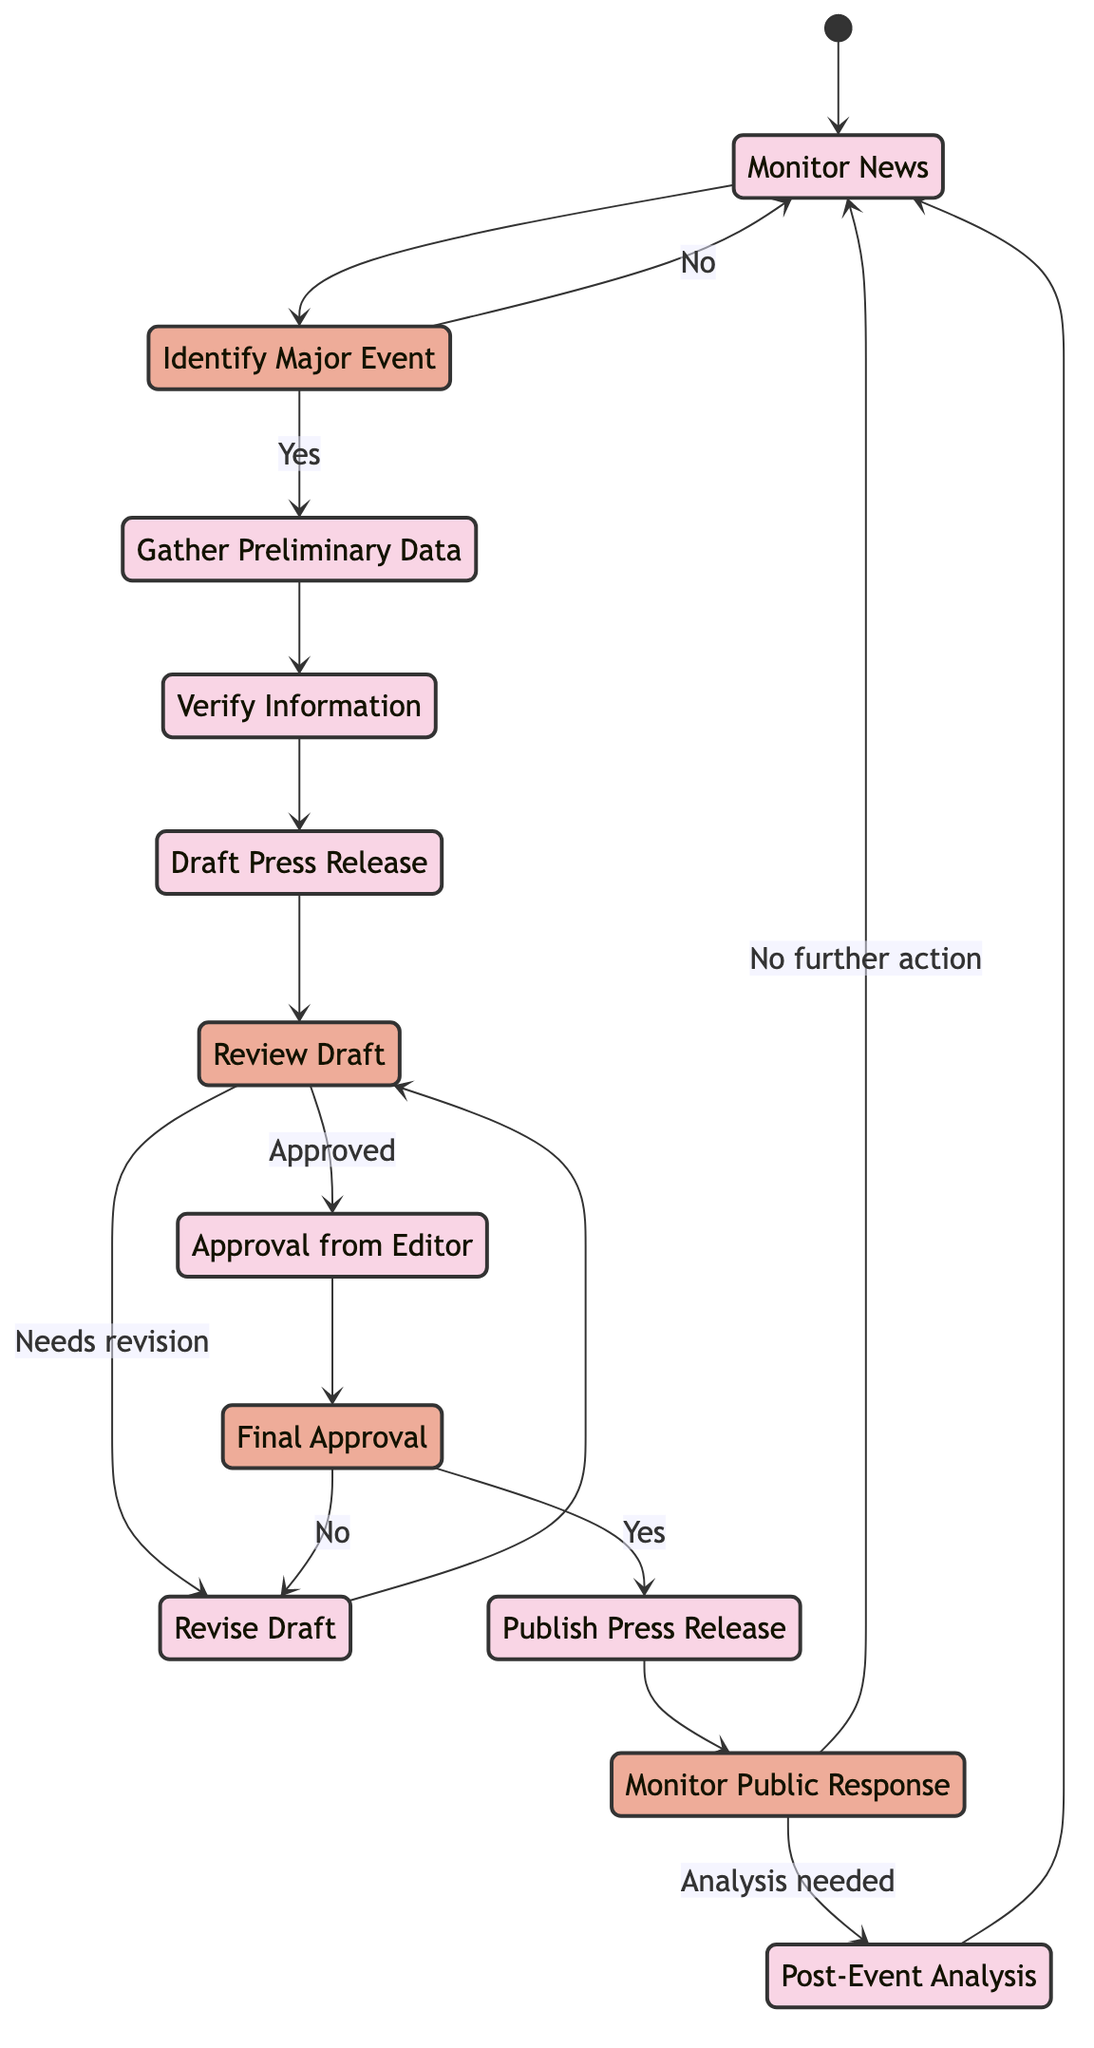What is the first activity in the workflow? The first activity in the workflow is "Monitor News". This can be seen as the starting point of the diagram, which directly leads into the next decision.
Answer: Monitor News How many decision nodes are present in the diagram? There are four decision nodes: "Identify Major Event", "Review Draft", "Final Approval", and "Monitor Public Response". Counting each of these decision points gives the total.
Answer: Four What activity follows after "Gather Preliminary Data"? Following "Gather Preliminary Data", the next activity is "Verify Information". This is indicated by the arrow connecting these two activities in the flow.
Answer: Verify Information What happens if the draft press release is approved after the review? If the draft is approved, the process moves to "Approval from Editor". This is indicated by the connection from "Review Draft" to "Approval from Editor".
Answer: Approval from Editor If the public response doesn't require further analysis, what is the next step? If no further analysis is needed, the workflow returns to "Monitor News". This is shown by the decision flow after "Monitor Public Response".
Answer: Monitor News Describe the flow after initial monitoring of news when a major event is identified. After monitoring news and identifying a major event, the workflow moves on to "Gather Preliminary Data", confirming that the event is significant. This is shown in the decision pathway of the diagram.
Answer: Gather Preliminary Data What is the last activity before returning to monitor news again? The last activity before returning to "Monitor News" is "Post-Event Analysis". Once the analysis is completed, it flows back to monitoring.
Answer: Post-Event Analysis What decision needs to be made after "Approval from Editor"? The decision to be made after "Approval from Editor" is "Final Approval". This indicates whether the press release is ready for publication.
Answer: Final Approval What decision occurs after reviewing the draft? The decision made after reviewing the draft is whether it needs revision or has been approved. This decision point determines the next steps in the workflow.
Answer: Review Draft 